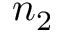<formula> <loc_0><loc_0><loc_500><loc_500>n _ { 2 }</formula> 